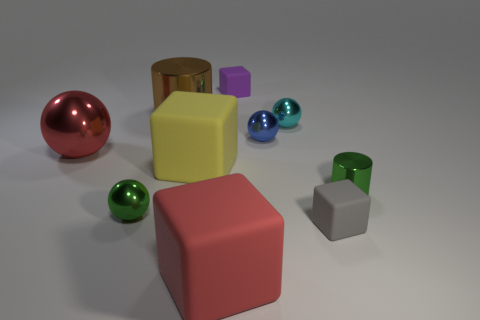Subtract all small balls. How many balls are left? 1 Subtract all green cylinders. How many cylinders are left? 1 Subtract all blocks. How many objects are left? 6 Subtract all yellow cylinders. How many yellow spheres are left? 0 Subtract all big red metal objects. Subtract all small gray cubes. How many objects are left? 8 Add 3 big yellow things. How many big yellow things are left? 4 Add 9 cyan shiny spheres. How many cyan shiny spheres exist? 10 Subtract 0 yellow spheres. How many objects are left? 10 Subtract 2 cylinders. How many cylinders are left? 0 Subtract all gray cylinders. Subtract all green blocks. How many cylinders are left? 2 